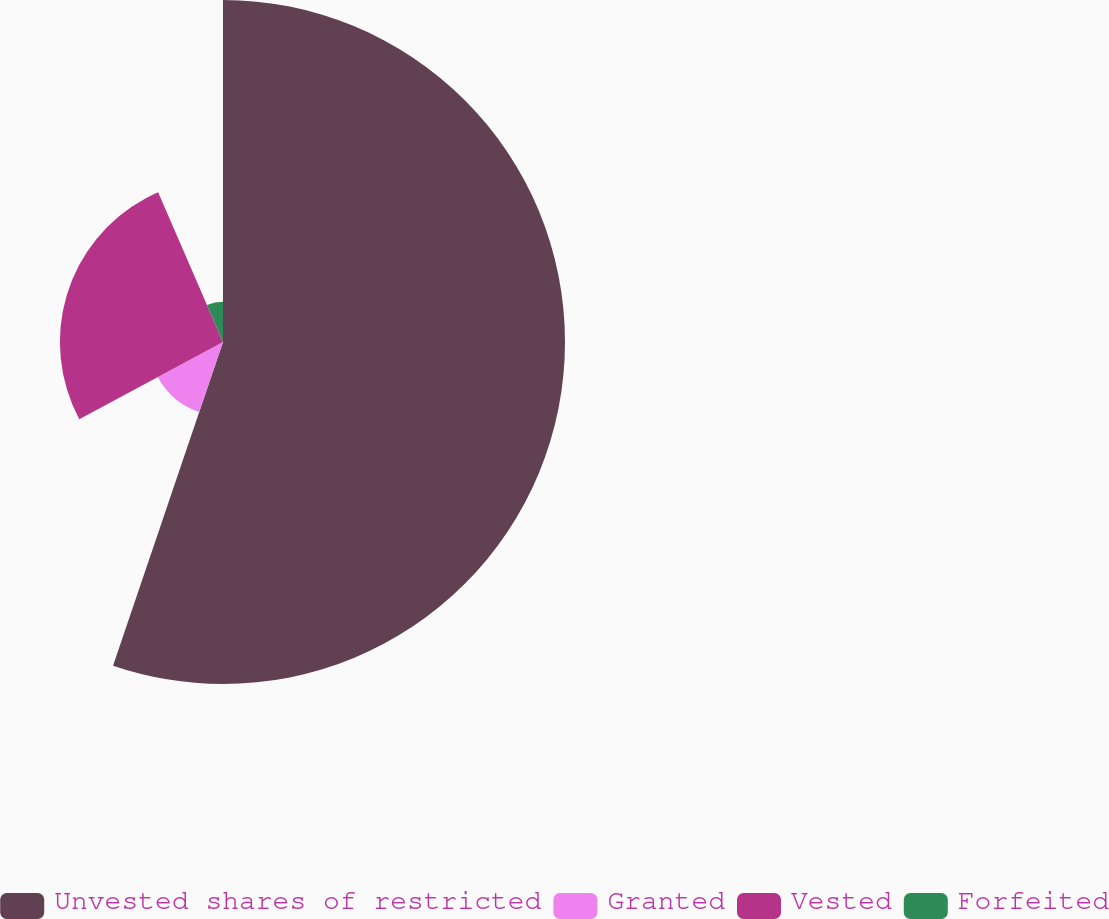Convert chart. <chart><loc_0><loc_0><loc_500><loc_500><pie_chart><fcel>Unvested shares of restricted<fcel>Granted<fcel>Vested<fcel>Forfeited<nl><fcel>55.21%<fcel>11.95%<fcel>26.33%<fcel>6.51%<nl></chart> 